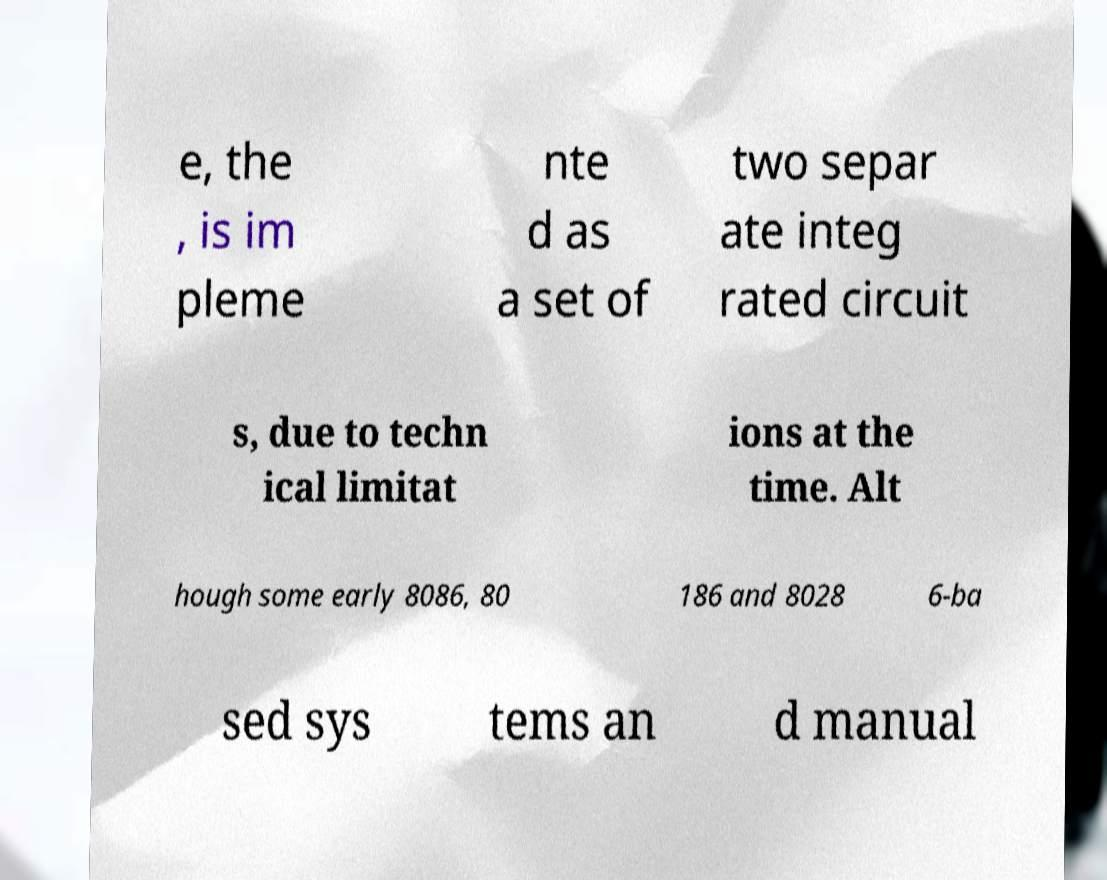Can you accurately transcribe the text from the provided image for me? e, the , is im pleme nte d as a set of two separ ate integ rated circuit s, due to techn ical limitat ions at the time. Alt hough some early 8086, 80 186 and 8028 6-ba sed sys tems an d manual 